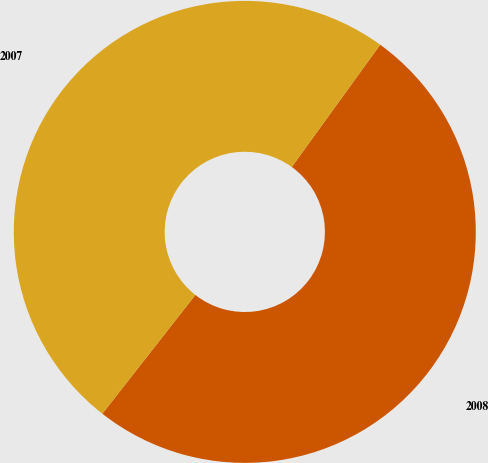Convert chart to OTSL. <chart><loc_0><loc_0><loc_500><loc_500><pie_chart><fcel>2008<fcel>2007<nl><fcel>50.61%<fcel>49.39%<nl></chart> 